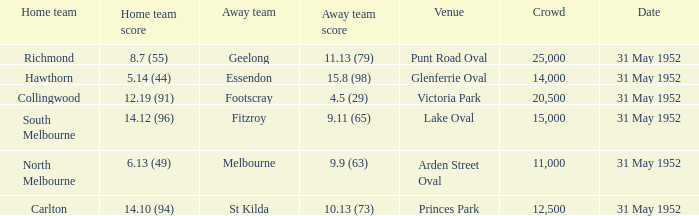Who was the away team at the game at Victoria Park? Footscray. 